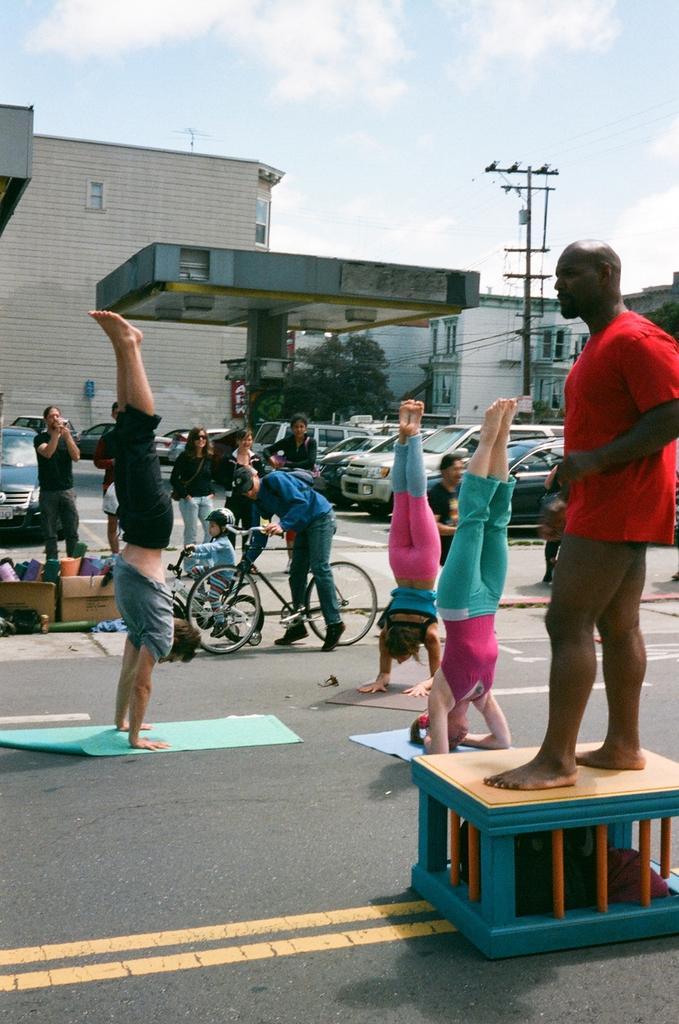Could you give a brief overview of what you see in this image? This 3 persons are doing yoga on road. This man is standing on box. This 2 persons are sitting on bicycle. Far this persons are standing. Vehicles are at parking area. Far there are buildings and tree. 